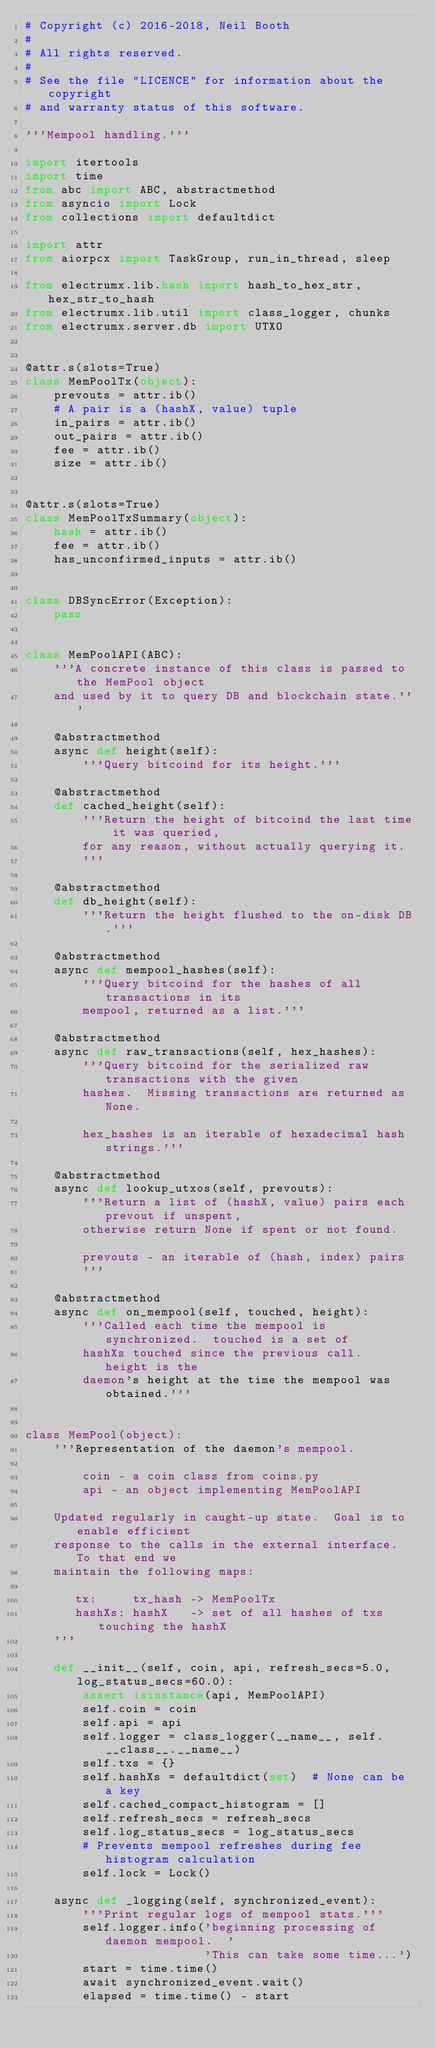Convert code to text. <code><loc_0><loc_0><loc_500><loc_500><_Python_># Copyright (c) 2016-2018, Neil Booth
#
# All rights reserved.
#
# See the file "LICENCE" for information about the copyright
# and warranty status of this software.

'''Mempool handling.'''

import itertools
import time
from abc import ABC, abstractmethod
from asyncio import Lock
from collections import defaultdict

import attr
from aiorpcx import TaskGroup, run_in_thread, sleep

from electrumx.lib.hash import hash_to_hex_str, hex_str_to_hash
from electrumx.lib.util import class_logger, chunks
from electrumx.server.db import UTXO


@attr.s(slots=True)
class MemPoolTx(object):
    prevouts = attr.ib()
    # A pair is a (hashX, value) tuple
    in_pairs = attr.ib()
    out_pairs = attr.ib()
    fee = attr.ib()
    size = attr.ib()


@attr.s(slots=True)
class MemPoolTxSummary(object):
    hash = attr.ib()
    fee = attr.ib()
    has_unconfirmed_inputs = attr.ib()


class DBSyncError(Exception):
    pass


class MemPoolAPI(ABC):
    '''A concrete instance of this class is passed to the MemPool object
    and used by it to query DB and blockchain state.'''

    @abstractmethod
    async def height(self):
        '''Query bitcoind for its height.'''

    @abstractmethod
    def cached_height(self):
        '''Return the height of bitcoind the last time it was queried,
        for any reason, without actually querying it.
        '''

    @abstractmethod
    def db_height(self):
        '''Return the height flushed to the on-disk DB.'''

    @abstractmethod
    async def mempool_hashes(self):
        '''Query bitcoind for the hashes of all transactions in its
        mempool, returned as a list.'''

    @abstractmethod
    async def raw_transactions(self, hex_hashes):
        '''Query bitcoind for the serialized raw transactions with the given
        hashes.  Missing transactions are returned as None.

        hex_hashes is an iterable of hexadecimal hash strings.'''

    @abstractmethod
    async def lookup_utxos(self, prevouts):
        '''Return a list of (hashX, value) pairs each prevout if unspent,
        otherwise return None if spent or not found.

        prevouts - an iterable of (hash, index) pairs
        '''

    @abstractmethod
    async def on_mempool(self, touched, height):
        '''Called each time the mempool is synchronized.  touched is a set of
        hashXs touched since the previous call.  height is the
        daemon's height at the time the mempool was obtained.'''


class MemPool(object):
    '''Representation of the daemon's mempool.

        coin - a coin class from coins.py
        api - an object implementing MemPoolAPI

    Updated regularly in caught-up state.  Goal is to enable efficient
    response to the calls in the external interface.  To that end we
    maintain the following maps:

       tx:     tx_hash -> MemPoolTx
       hashXs: hashX   -> set of all hashes of txs touching the hashX
    '''

    def __init__(self, coin, api, refresh_secs=5.0, log_status_secs=60.0):
        assert isinstance(api, MemPoolAPI)
        self.coin = coin
        self.api = api
        self.logger = class_logger(__name__, self.__class__.__name__)
        self.txs = {}
        self.hashXs = defaultdict(set)  # None can be a key
        self.cached_compact_histogram = []
        self.refresh_secs = refresh_secs
        self.log_status_secs = log_status_secs
        # Prevents mempool refreshes during fee histogram calculation
        self.lock = Lock()

    async def _logging(self, synchronized_event):
        '''Print regular logs of mempool stats.'''
        self.logger.info('beginning processing of daemon mempool.  '
                         'This can take some time...')
        start = time.time()
        await synchronized_event.wait()
        elapsed = time.time() - start</code> 